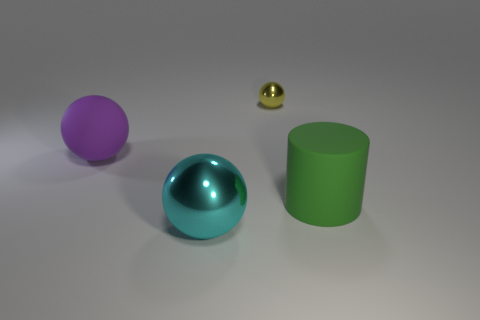The thing that is both on the right side of the cyan shiny object and in front of the purple rubber sphere is what color?
Make the answer very short. Green. Is the number of cyan things to the left of the tiny yellow object greater than the number of big cyan metal balls in front of the cyan shiny object?
Offer a very short reply. Yes. What size is the other ball that is made of the same material as the large cyan ball?
Your response must be concise. Small. There is a rubber object in front of the purple sphere; how many big green things are behind it?
Give a very brief answer. 0. Are there any purple rubber objects that have the same shape as the small metallic object?
Make the answer very short. Yes. What is the color of the metallic sphere left of the ball on the right side of the big cyan metallic thing?
Your answer should be very brief. Cyan. Is the number of small yellow things greater than the number of small green rubber things?
Ensure brevity in your answer.  Yes. How many other metal objects have the same size as the yellow shiny thing?
Provide a succinct answer. 0. Is the material of the tiny yellow ball the same as the large sphere that is on the right side of the matte ball?
Provide a succinct answer. Yes. Is the number of large cylinders less than the number of green matte blocks?
Keep it short and to the point. No. 